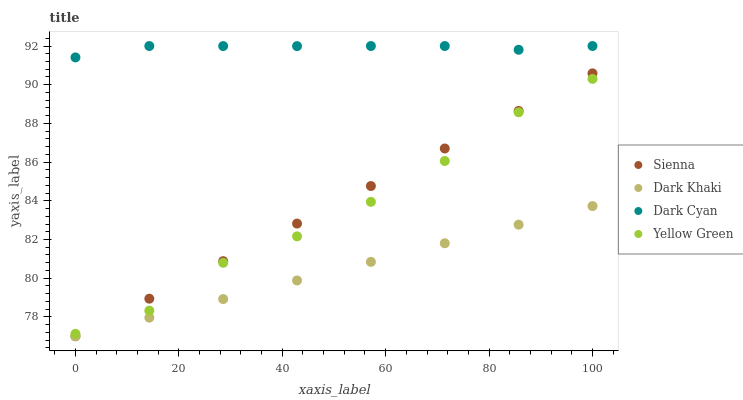Does Dark Khaki have the minimum area under the curve?
Answer yes or no. Yes. Does Dark Cyan have the maximum area under the curve?
Answer yes or no. Yes. Does Dark Cyan have the minimum area under the curve?
Answer yes or no. No. Does Dark Khaki have the maximum area under the curve?
Answer yes or no. No. Is Dark Khaki the smoothest?
Answer yes or no. Yes. Is Yellow Green the roughest?
Answer yes or no. Yes. Is Dark Cyan the smoothest?
Answer yes or no. No. Is Dark Cyan the roughest?
Answer yes or no. No. Does Sienna have the lowest value?
Answer yes or no. Yes. Does Dark Cyan have the lowest value?
Answer yes or no. No. Does Dark Cyan have the highest value?
Answer yes or no. Yes. Does Dark Khaki have the highest value?
Answer yes or no. No. Is Dark Khaki less than Yellow Green?
Answer yes or no. Yes. Is Yellow Green greater than Dark Khaki?
Answer yes or no. Yes. Does Sienna intersect Dark Khaki?
Answer yes or no. Yes. Is Sienna less than Dark Khaki?
Answer yes or no. No. Is Sienna greater than Dark Khaki?
Answer yes or no. No. Does Dark Khaki intersect Yellow Green?
Answer yes or no. No. 